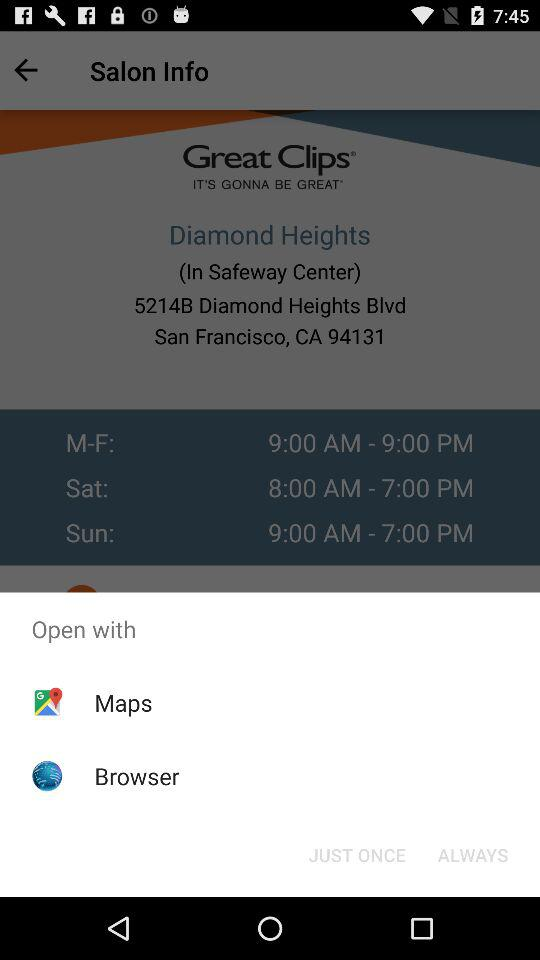Through what application can it be opened? The applications are "Maps" and "Browser". 